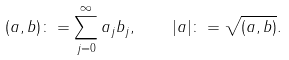<formula> <loc_0><loc_0><loc_500><loc_500>( a , b ) \colon = \sum _ { j = 0 } ^ { \infty } a _ { j } b _ { j } , \quad | a | \colon = \sqrt { ( a , b ) } .</formula> 